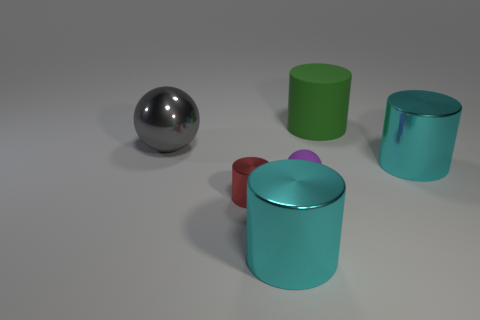Subtract 2 cylinders. How many cylinders are left? 2 Subtract all purple cylinders. Subtract all yellow blocks. How many cylinders are left? 4 Add 1 tiny shiny cylinders. How many objects exist? 7 Subtract all cylinders. How many objects are left? 2 Subtract all small spheres. Subtract all small gray matte cylinders. How many objects are left? 5 Add 6 big shiny objects. How many big shiny objects are left? 9 Add 2 small cyan objects. How many small cyan objects exist? 2 Subtract 0 yellow cylinders. How many objects are left? 6 